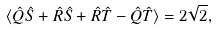<formula> <loc_0><loc_0><loc_500><loc_500>\langle \hat { Q } \hat { S } + \hat { R } \hat { S } + \hat { R } \hat { T } - \hat { Q } \hat { T } \rangle = 2 { \sqrt { 2 } } ,</formula> 